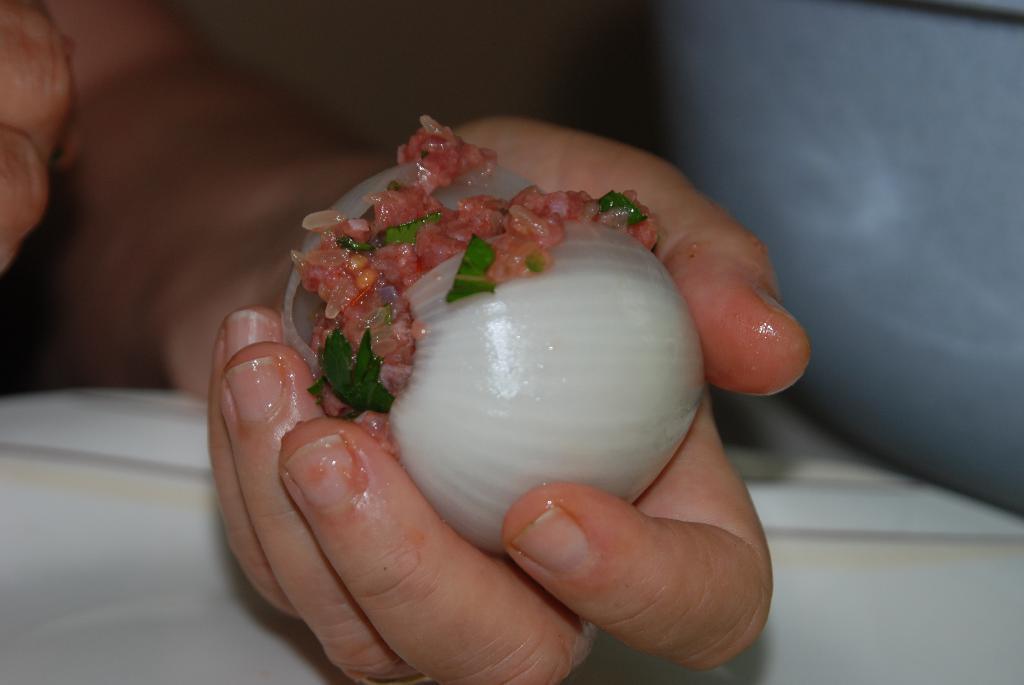Please provide a concise description of this image. Here in this picture we can see a person's hand holding an onion with something stuffed in it. 